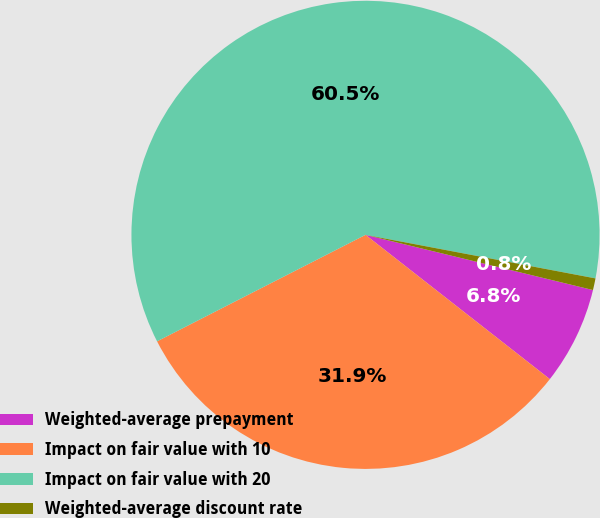Convert chart. <chart><loc_0><loc_0><loc_500><loc_500><pie_chart><fcel>Weighted-average prepayment<fcel>Impact on fair value with 10<fcel>Impact on fair value with 20<fcel>Weighted-average discount rate<nl><fcel>6.78%<fcel>31.91%<fcel>60.49%<fcel>0.81%<nl></chart> 